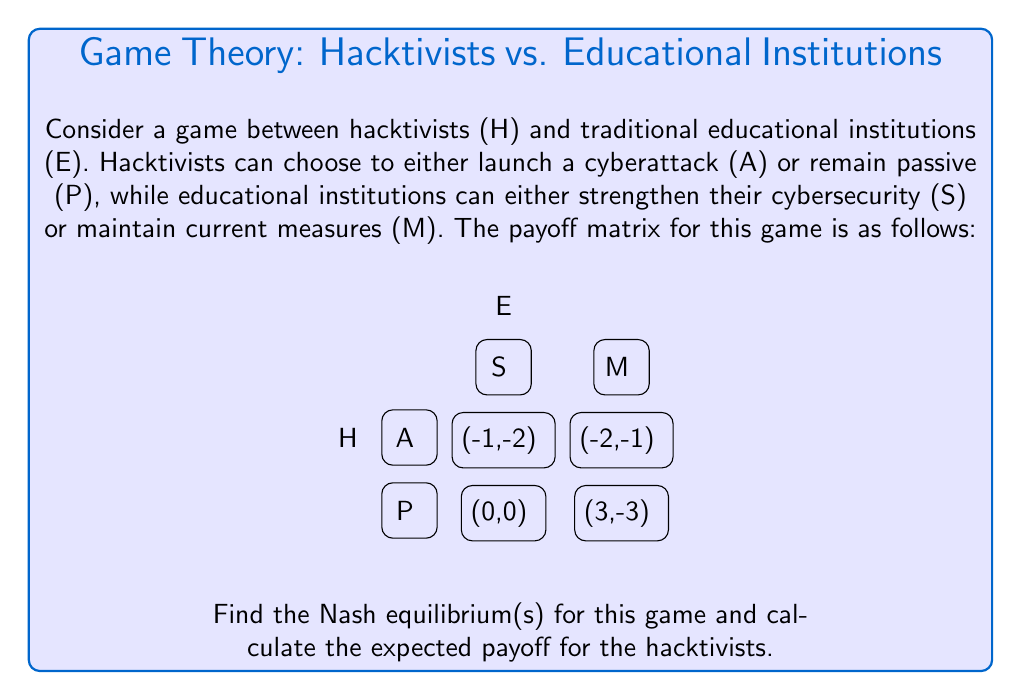Can you solve this math problem? To solve this game theory problem, we'll follow these steps:

1) Identify dominant strategies:
   For Hacktivists (H):
   - If E chooses S: -1 > -2, so P is better
   - If E chooses M: 3 > 0, so A is better
   No dominant strategy for H

   For Educational Institutions (E):
   - If H chooses A: -1 > -3, so S is better
   - If H chooses P: 0 > -1, so M is better
   No dominant strategy for E

2) Find Nash Equilibrium:
   We'll use the best response method:
   - If H chooses A, E's best response is S
   - If H chooses P, E's best response is M
   - If E chooses S, H's best response is P
   - If E chooses M, H's best response is A

   The Nash Equilibrium occurs where best responses intersect. In this case, there are two:
   (A, S) and (P, M)

3) Calculate expected payoff for Hacktivists:
   We have two equilibria, so we'll calculate the average:

   For (A, S): Payoff = -1
   For (P, M): Payoff = 0

   Expected payoff = $\frac{-1 + 0}{2} = -0.5$

Therefore, the Nash equilibria are (A, S) and (P, M), and the expected payoff for hacktivists is -0.5.
Answer: Nash equilibria: (A, S) and (P, M); Expected payoff for hacktivists: -0.5 